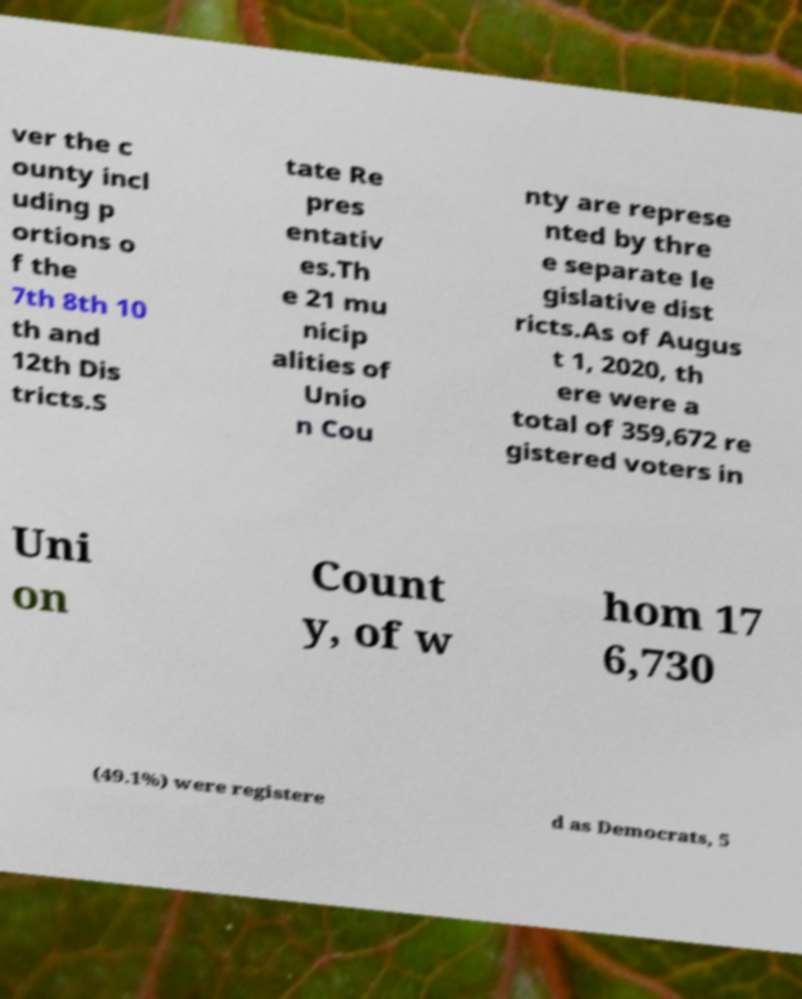Please read and relay the text visible in this image. What does it say? ver the c ounty incl uding p ortions o f the 7th 8th 10 th and 12th Dis tricts.S tate Re pres entativ es.Th e 21 mu nicip alities of Unio n Cou nty are represe nted by thre e separate le gislative dist ricts.As of Augus t 1, 2020, th ere were a total of 359,672 re gistered voters in Uni on Count y, of w hom 17 6,730 (49.1%) were registere d as Democrats, 5 